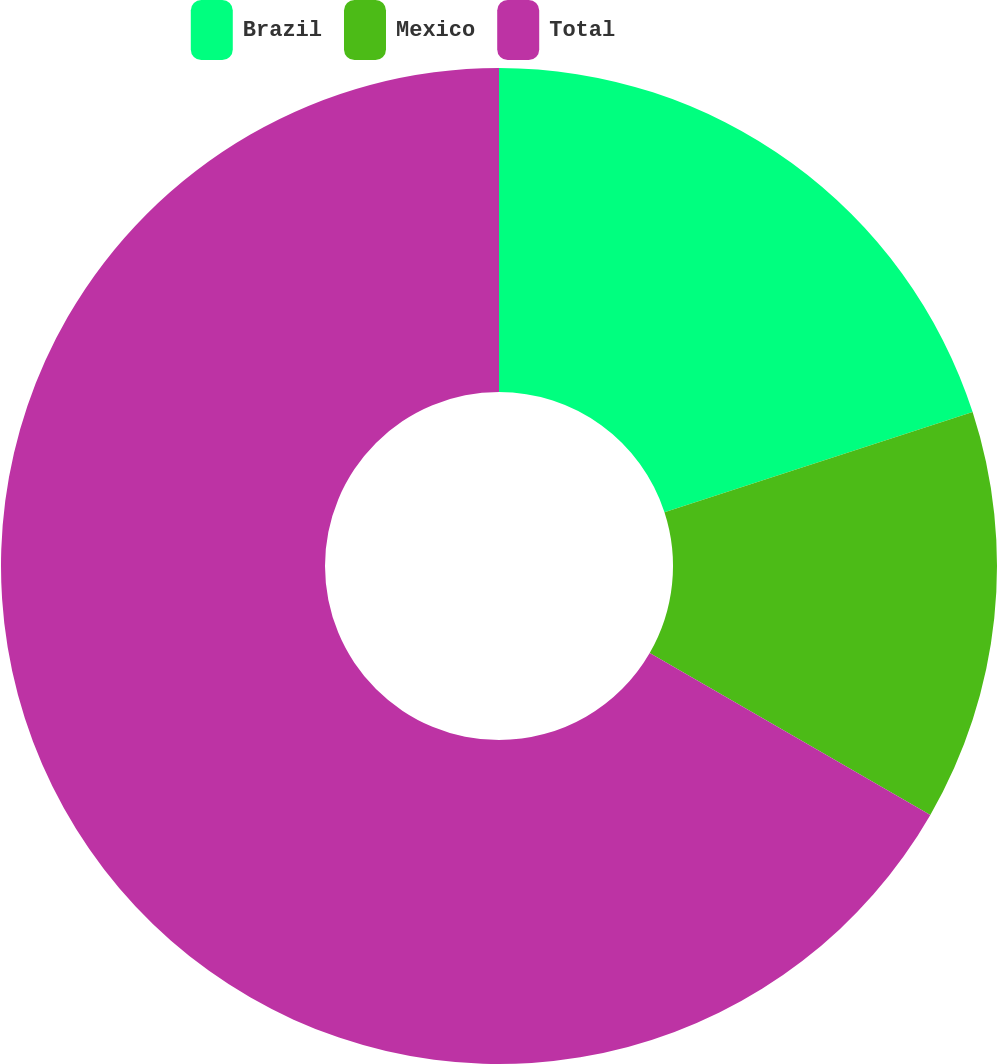Convert chart. <chart><loc_0><loc_0><loc_500><loc_500><pie_chart><fcel>Brazil<fcel>Mexico<fcel>Total<nl><fcel>20.0%<fcel>13.33%<fcel>66.67%<nl></chart> 